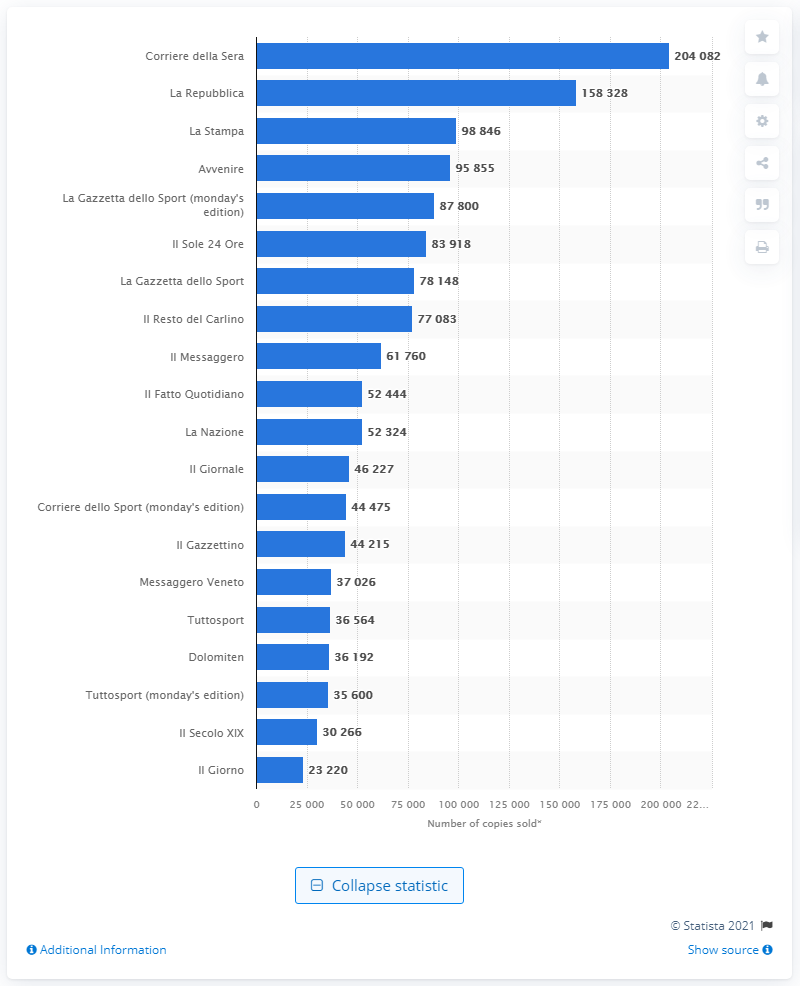Highlight a few significant elements in this photo. In December of 2020, Corriere della Sera sold a total of 204,082 copies. In December of 2020, La Repubblica sold a total of 158,328 copies. In December of 2020, Corriere della Sera was the most widely read daily newspaper in Italy. 